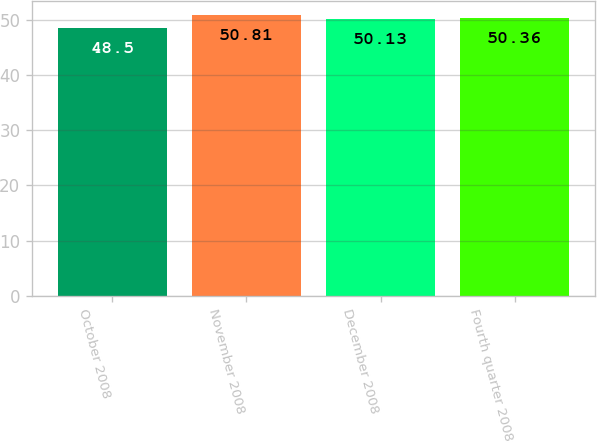Convert chart. <chart><loc_0><loc_0><loc_500><loc_500><bar_chart><fcel>October 2008<fcel>November 2008<fcel>December 2008<fcel>Fourth quarter 2008<nl><fcel>48.5<fcel>50.81<fcel>50.13<fcel>50.36<nl></chart> 